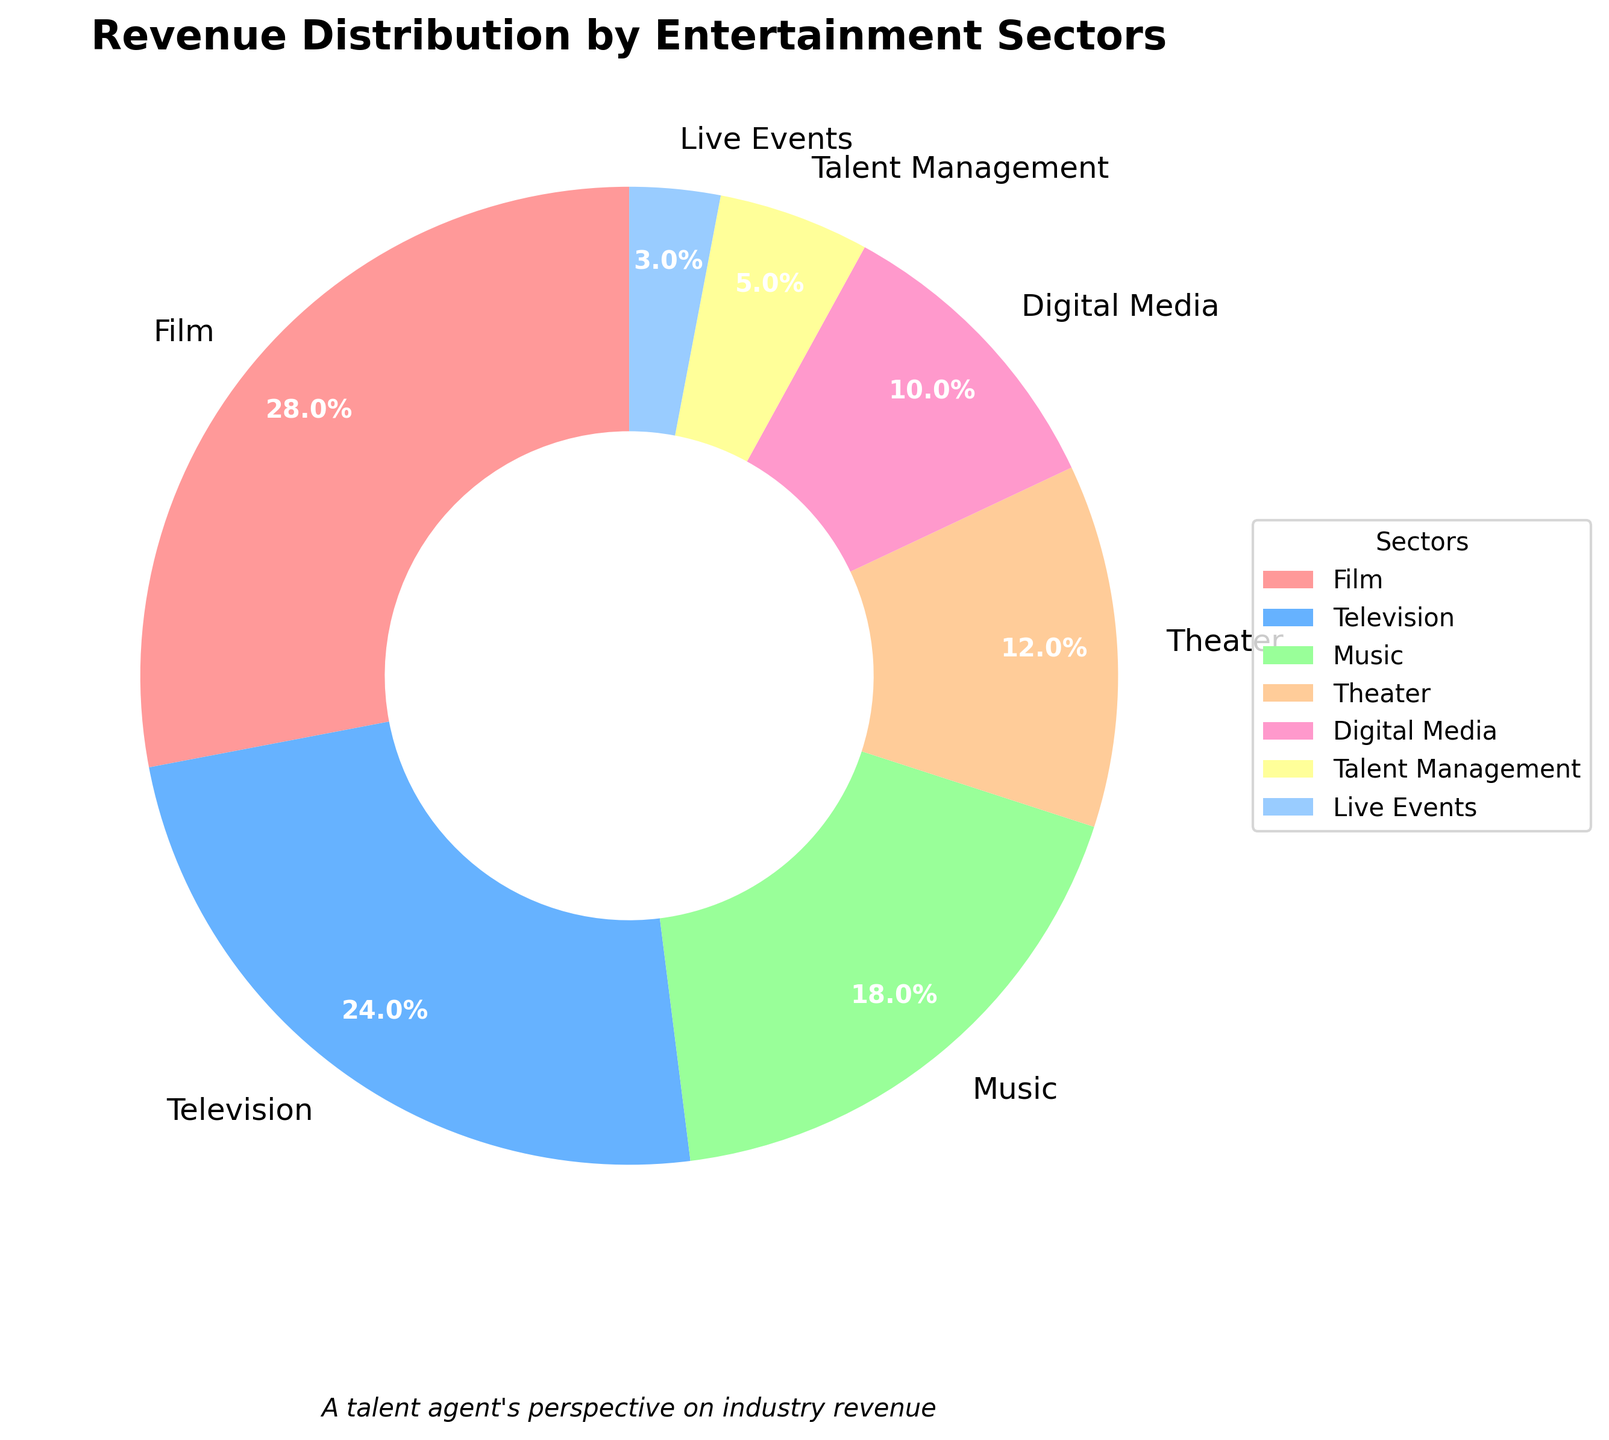What sector has the largest revenue distribution? The largest segment in the pie chart is the Film sector based on the visible area.
Answer: Film What is the combined revenue percentage for Television and Music sectors? From the pie chart, the Television sector has 24% and the Music sector has 18%. Adding these two percentages together, 24% + 18% = 42%.
Answer: 42% Which sector has a smaller revenue percentage: Digital Media or Theater? By comparing the two sectors in the pie chart, Digital Media has 10% and Theater has 12%. Therefore, Digital Media has a smaller revenue percentage.
Answer: Digital Media How much greater is the revenue percentage of Film compared to Theater? The Film sector has 28% and the Theater sector has 12% as shown in the pie chart. The difference is 28% - 12% = 16%.
Answer: 16% What is the total revenue percentage contributed by Talent Management and Live Events? The pie chart shows Talent Management with 5% and Live Events with 3%. Adding these, 5% + 3% = 8%.
Answer: 8% Which sectors have a revenue percentage greater than 20%? In the pie chart, the sectors Film (28%) and Television (24%) show percentages greater than 20%.
Answer: Film, Television What is the difference in revenue percentage between the highest and lowest sectors? The highest revenue percentage is from the Film sector with 28%, and the lowest is from Live Events with 3%. The difference is 28% - 3% = 25%.
Answer: 25% Arrange the sectors in descending order of their revenue percentages. Referring to the pie chart segments from largest to smallest: Film (28%), Television (24%), Music (18%), Theater (12%), Digital Media (10%), Talent Management (5%), Live Events (3%).
Answer: Film, Television, Music, Theater, Digital Media, Talent Management, Live Events Which sector's label color is closest to red? In the pie chart, the Film sector is labeled with a color closest to red.
Answer: Film What is the average revenue percentage of Digital Media, Talent Management, and Live Events sectors? The percentages for Digital Media, Talent Management, and Live Events are 10%, 5%, and 3% respectively. The average is calculated as (10 + 5 + 3) / 3 = 6%.
Answer: 6% 